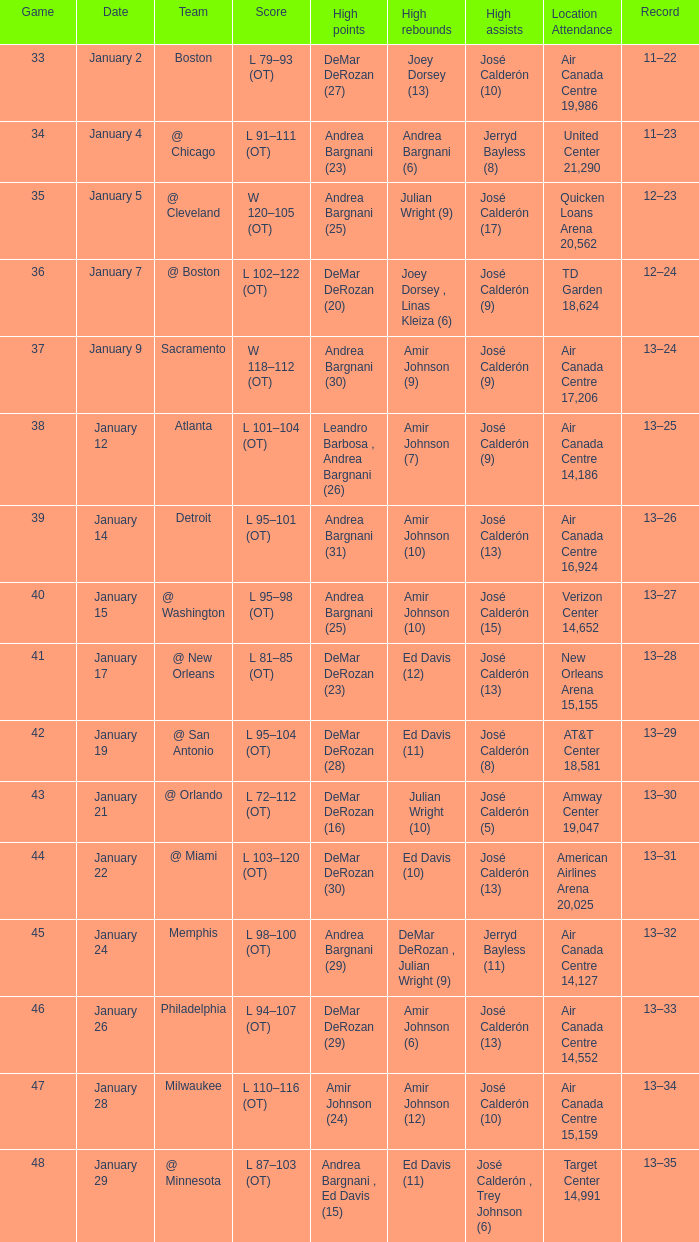Which team is designated for january 17th? @ New Orleans. 